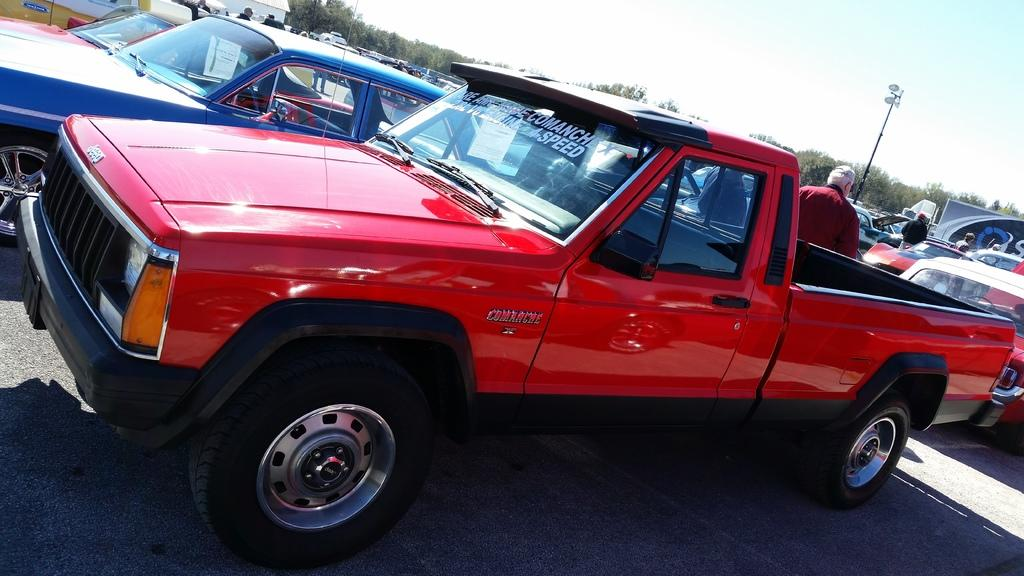What can be seen on the road in the image? There are many cars on the road in the image. Who or what can be seen in the image besides the cars? There are people visible in the image. What is in the background of the image? There are trees and a pole in the background. What is visible at the top of the image? The sky is visible at the top of the image. What type of power is being generated by the dolls in the image? There are no dolls present in the image, so the question cannot be answered. 